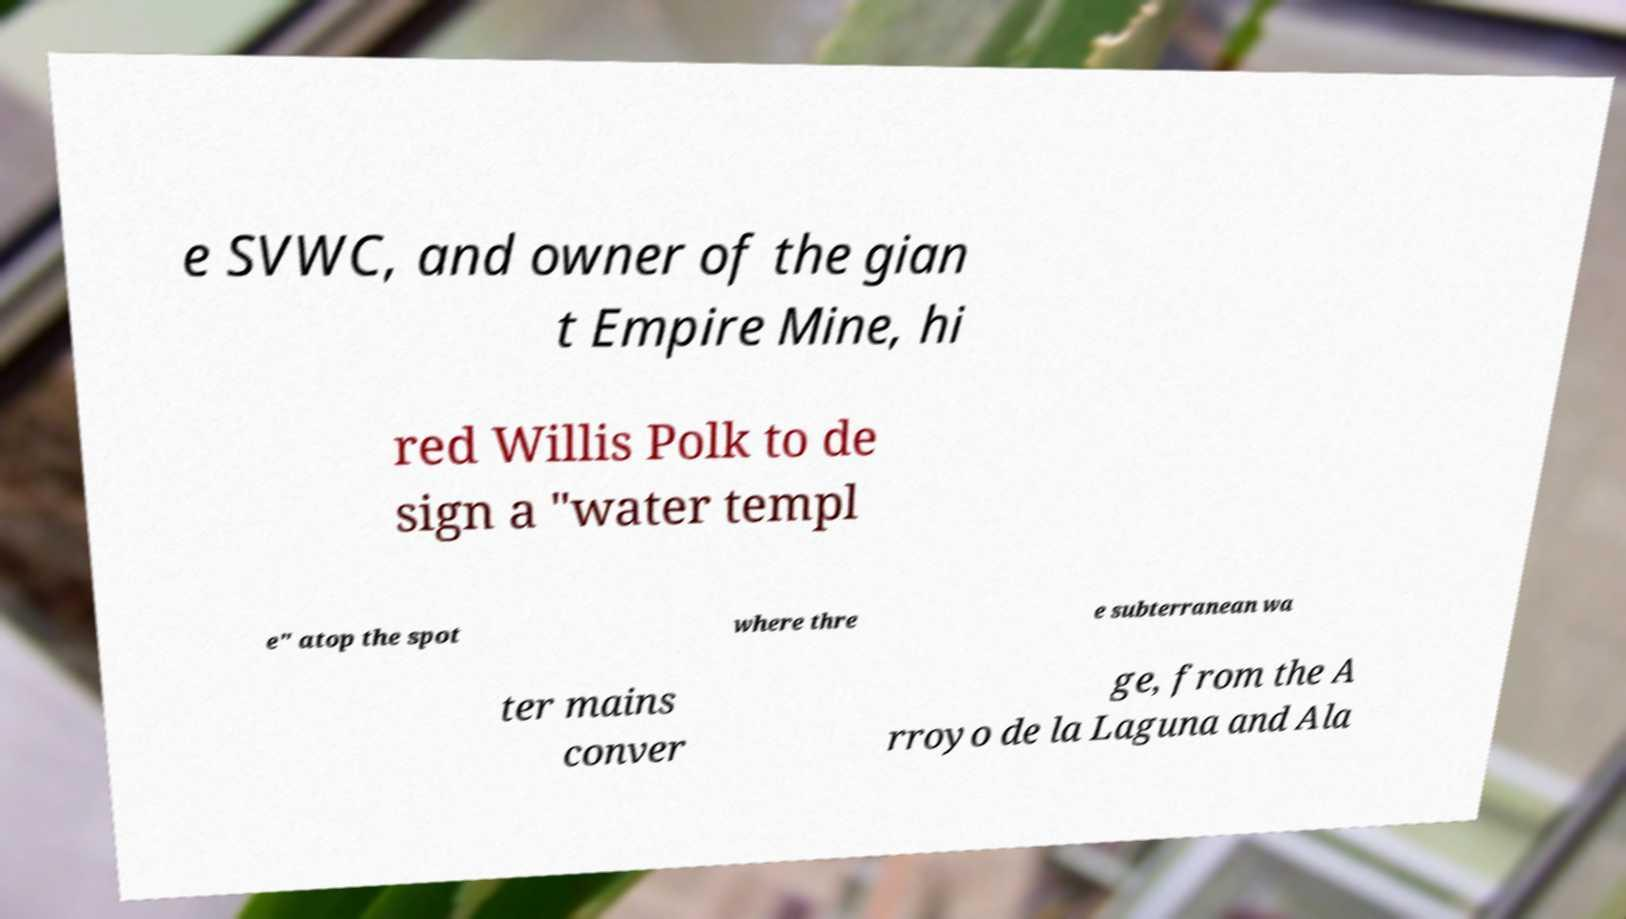Please read and relay the text visible in this image. What does it say? e SVWC, and owner of the gian t Empire Mine, hi red Willis Polk to de sign a "water templ e" atop the spot where thre e subterranean wa ter mains conver ge, from the A rroyo de la Laguna and Ala 